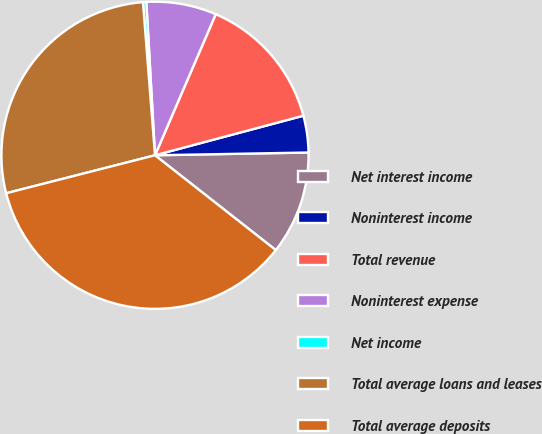Convert chart to OTSL. <chart><loc_0><loc_0><loc_500><loc_500><pie_chart><fcel>Net interest income<fcel>Noninterest income<fcel>Total revenue<fcel>Noninterest expense<fcel>Net income<fcel>Total average loans and leases<fcel>Total average deposits<nl><fcel>10.88%<fcel>3.86%<fcel>14.38%<fcel>7.37%<fcel>0.35%<fcel>27.73%<fcel>35.43%<nl></chart> 